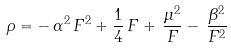<formula> <loc_0><loc_0><loc_500><loc_500>\rho = - \, \alpha ^ { 2 } \, F ^ { 2 } + \frac { 1 } { 4 } \, F + \, \frac { \mu ^ { 2 } } { F } - \, \frac { \beta ^ { 2 } } { F ^ { 2 } }</formula> 